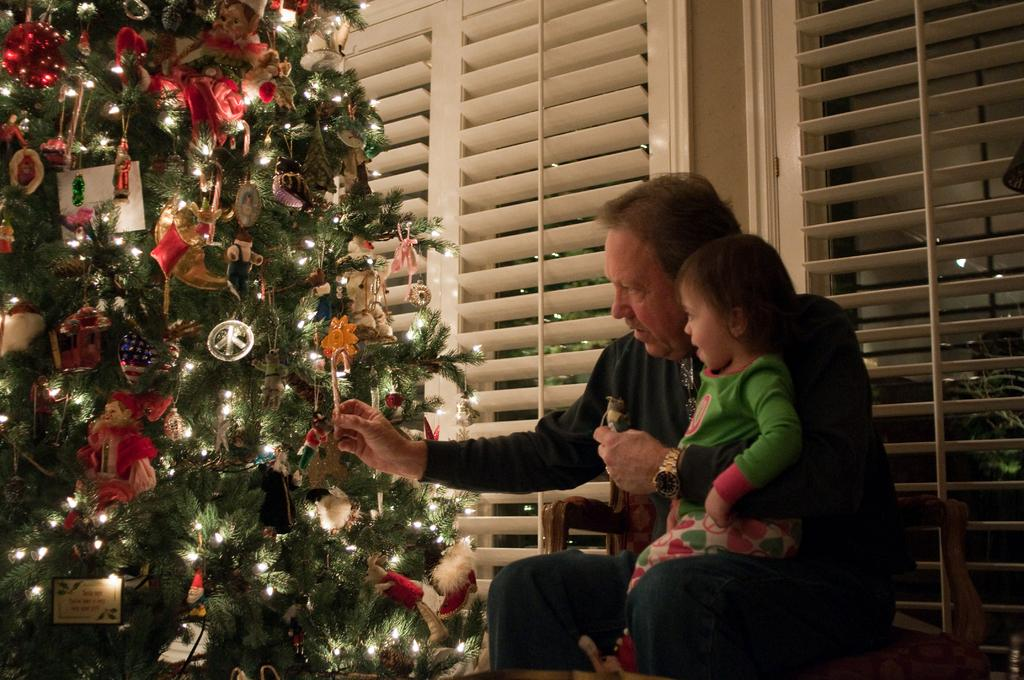Where is the person sitting in the image? The person is sitting on a chair in the bottom right side of the image. What is the person holding in the image? The person is holding a baby. What can be seen behind the person? There is a window behind the person. What is located in the bottom left side of the image? There is a Christmas tree in the bottom left side of the image. What is the person writing on the chair in the image? There is no indication that the person is writing in the image, and the chair is not mentioned as a surface for writing. 